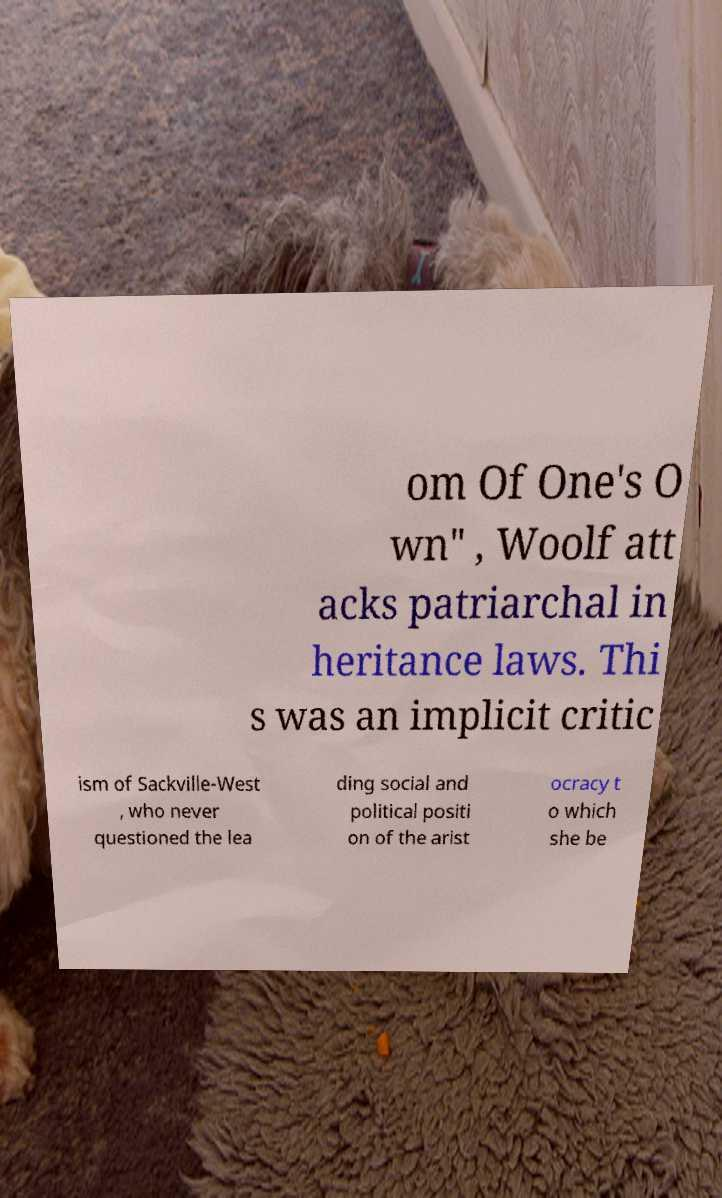Please identify and transcribe the text found in this image. om Of One's O wn" , Woolf att acks patriarchal in heritance laws. Thi s was an implicit critic ism of Sackville-West , who never questioned the lea ding social and political positi on of the arist ocracy t o which she be 